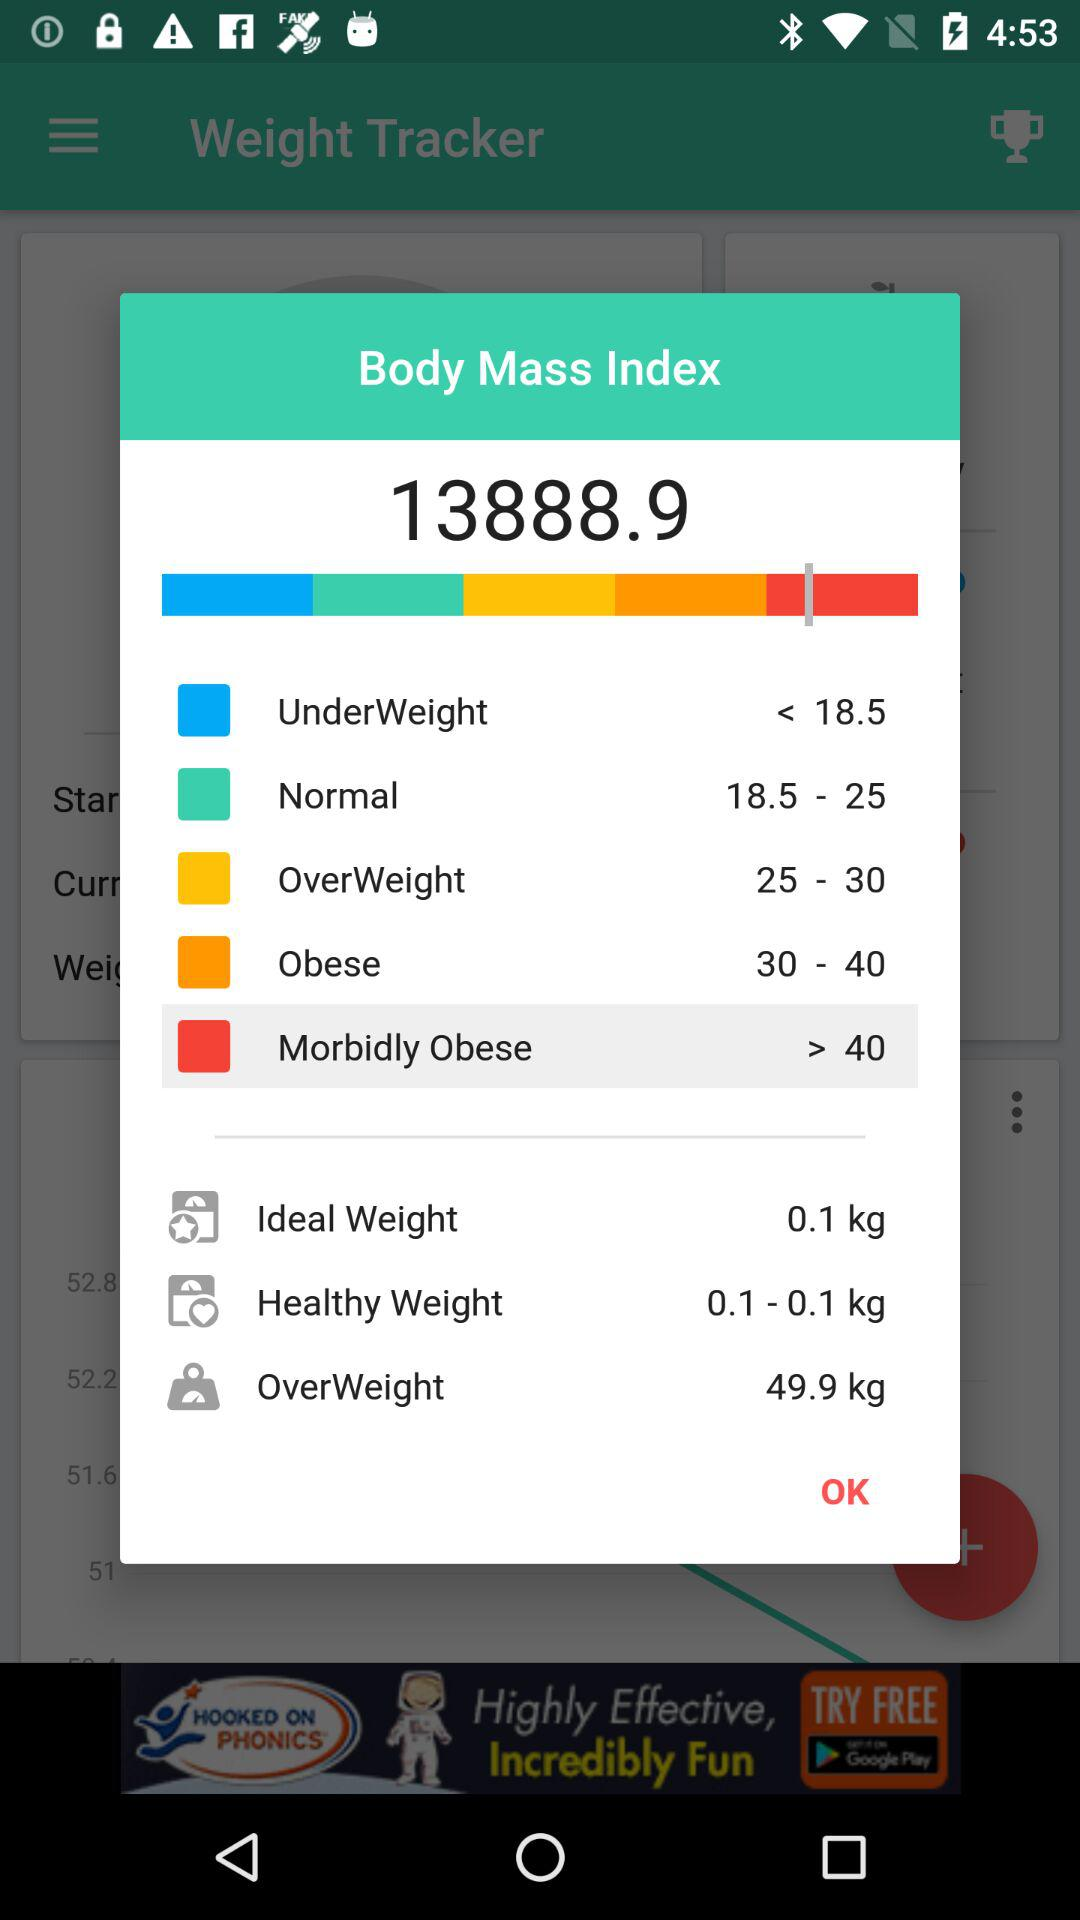What is the Under Weight ratio? The Under Weight ratio is < 18.5. 